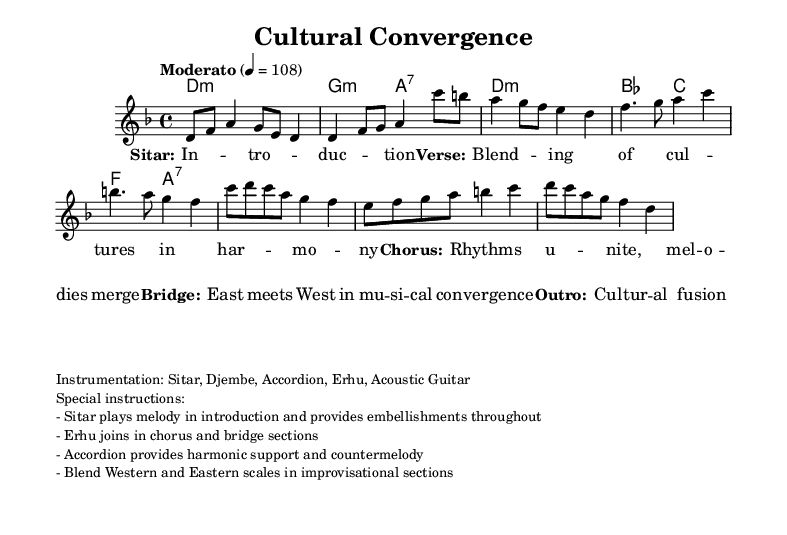What is the key signature of this music? The key signature shown in the score is D minor, which is indicated by one flat (B♭) and suggests that the piece primarily uses the notes from the D minor scale.
Answer: D minor What is the time signature of the piece? The time signature displayed in the sheet music is 4/4, meaning there are four beats in each measure, and each quarter note gets one beat.
Answer: 4/4 What is the tempo marking for this composition? The tempo marking states "Moderato" with a metronome marking of 4 = 108, suggesting that the piece should be played at a moderate speed of 108 beats per minute.
Answer: Moderato How many distinct sections are present in this composition? By examining the structure of the score, we can identify five distinct sections: Introduction, Verse, Chorus, Bridge, and Outro, each with its own unique musical content.
Answer: Five Which instruments are used in this piece? The instrumentation is listed in the markup, indicating the specific instruments included: Sitar, Djembe, Accordion, Erhu, and Acoustic Guitar, all contributing to the cross-cultural sound.
Answer: Sitar, Djembe, Accordion, Erhu, Acoustic Guitar What musical idea is highlighted in the bridge section? The bridge section explicitly emphasizes the idea of "East meets West in musical convergence," showcasing the blending of different musical traditions and styles.
Answer: East meets West What harmonic structures are present in this composition? The harmonic structures are indicated in the chord symbols, showing a mix of minor and dominant seventh chords, particularly focusing on D minor, G minor, and A7, which creates a rich harmonic backdrop.
Answer: D minor, G minor, A7 